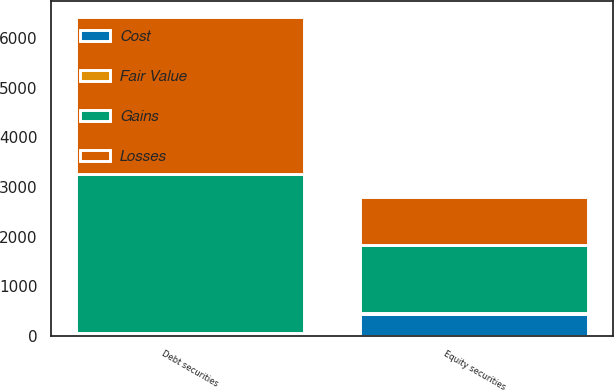Convert chart to OTSL. <chart><loc_0><loc_0><loc_500><loc_500><stacked_bar_chart><ecel><fcel>Equity securities<fcel>Debt securities<nl><fcel>Losses<fcel>957<fcel>3169<nl><fcel>Cost<fcel>441<fcel>46<nl><fcel>Fair Value<fcel>10<fcel>10<nl><fcel>Gains<fcel>1388<fcel>3205<nl></chart> 